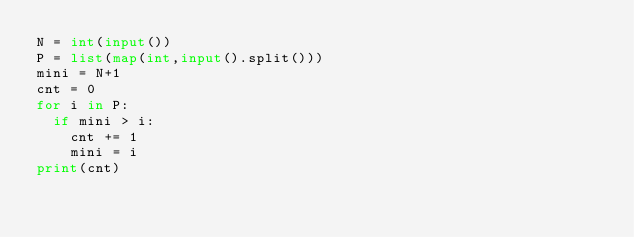<code> <loc_0><loc_0><loc_500><loc_500><_Python_>N = int(input())
P = list(map(int,input().split()))
mini = N+1
cnt = 0
for i in P:
  if mini > i:
    cnt += 1
    mini = i
print(cnt)</code> 